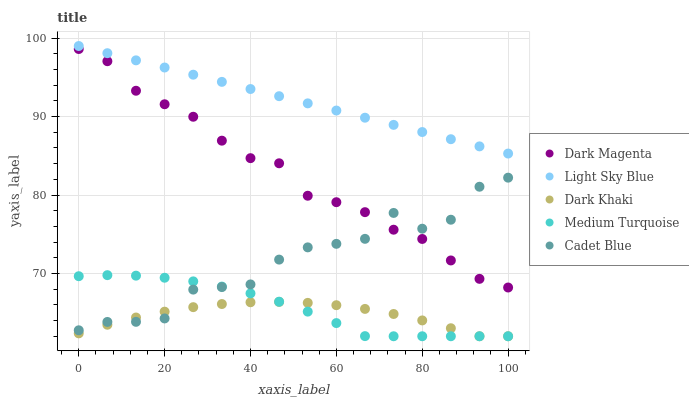Does Dark Khaki have the minimum area under the curve?
Answer yes or no. Yes. Does Light Sky Blue have the maximum area under the curve?
Answer yes or no. Yes. Does Cadet Blue have the minimum area under the curve?
Answer yes or no. No. Does Cadet Blue have the maximum area under the curve?
Answer yes or no. No. Is Light Sky Blue the smoothest?
Answer yes or no. Yes. Is Cadet Blue the roughest?
Answer yes or no. Yes. Is Cadet Blue the smoothest?
Answer yes or no. No. Is Light Sky Blue the roughest?
Answer yes or no. No. Does Dark Khaki have the lowest value?
Answer yes or no. Yes. Does Cadet Blue have the lowest value?
Answer yes or no. No. Does Light Sky Blue have the highest value?
Answer yes or no. Yes. Does Cadet Blue have the highest value?
Answer yes or no. No. Is Medium Turquoise less than Light Sky Blue?
Answer yes or no. Yes. Is Light Sky Blue greater than Medium Turquoise?
Answer yes or no. Yes. Does Cadet Blue intersect Dark Magenta?
Answer yes or no. Yes. Is Cadet Blue less than Dark Magenta?
Answer yes or no. No. Is Cadet Blue greater than Dark Magenta?
Answer yes or no. No. Does Medium Turquoise intersect Light Sky Blue?
Answer yes or no. No. 